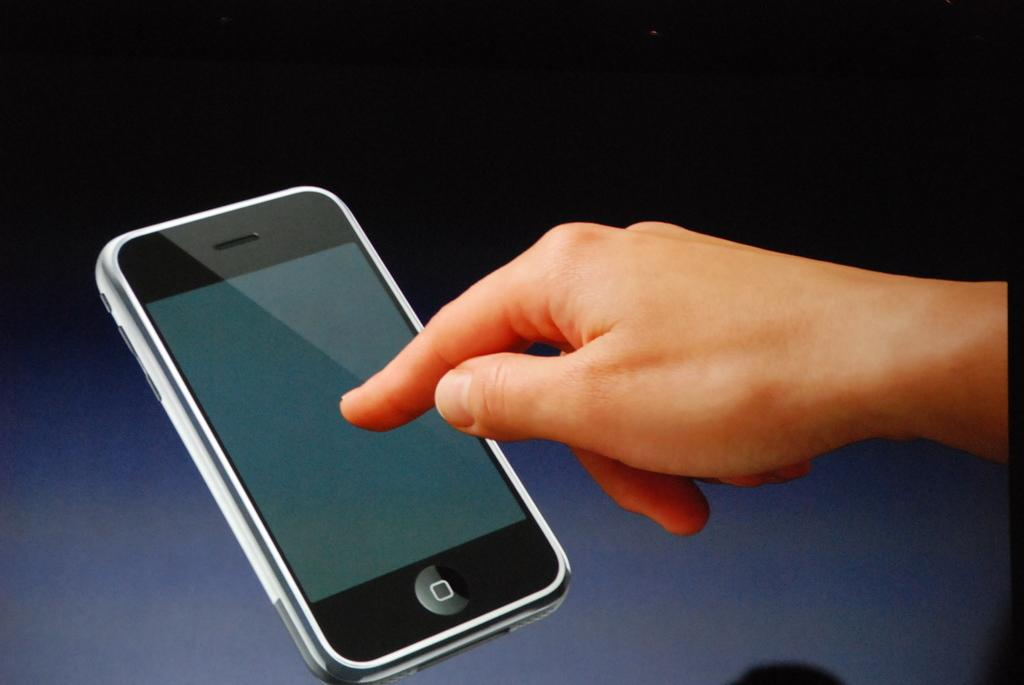What is the person doing in the image? A person's hand is touching a mobile screen in the image. What color can be seen in the background of the image? There is a blue color in the background of the image. Can you describe the setting of the image? The image may have been taken in a room, as it is a common place for using mobile devices. Can you see a yak grazing on the ground in the image? No, there is no yak or ground visible in the image. Is there a battle taking place in the image? No, there is no indication of a battle or any conflict in the image. 